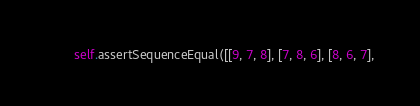<code> <loc_0><loc_0><loc_500><loc_500><_Python_>        self.assertSequenceEqual([[9, 7, 8], [7, 8, 6], [8, 6, 7],</code> 